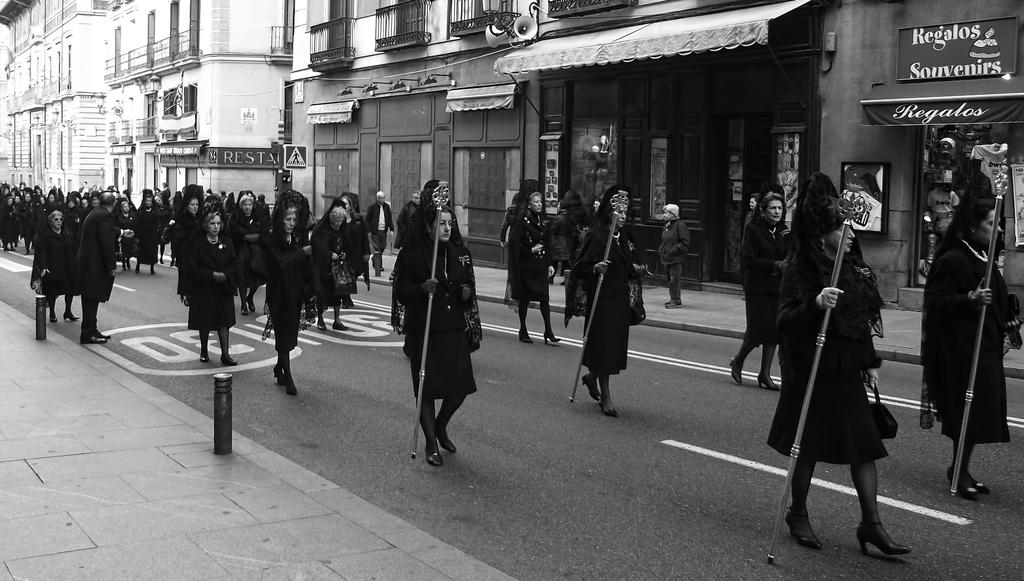What can be seen in the image? There is a group of people in the image. What are the people wearing? The people are wearing black dress. What are some people in the group holding? Some people in the group are holding a stick. What can be seen in the background of the image? There are buildings in the background of the image. Are there any animals from the zoo present in the image? There is no mention of animals or a zoo in the image. 